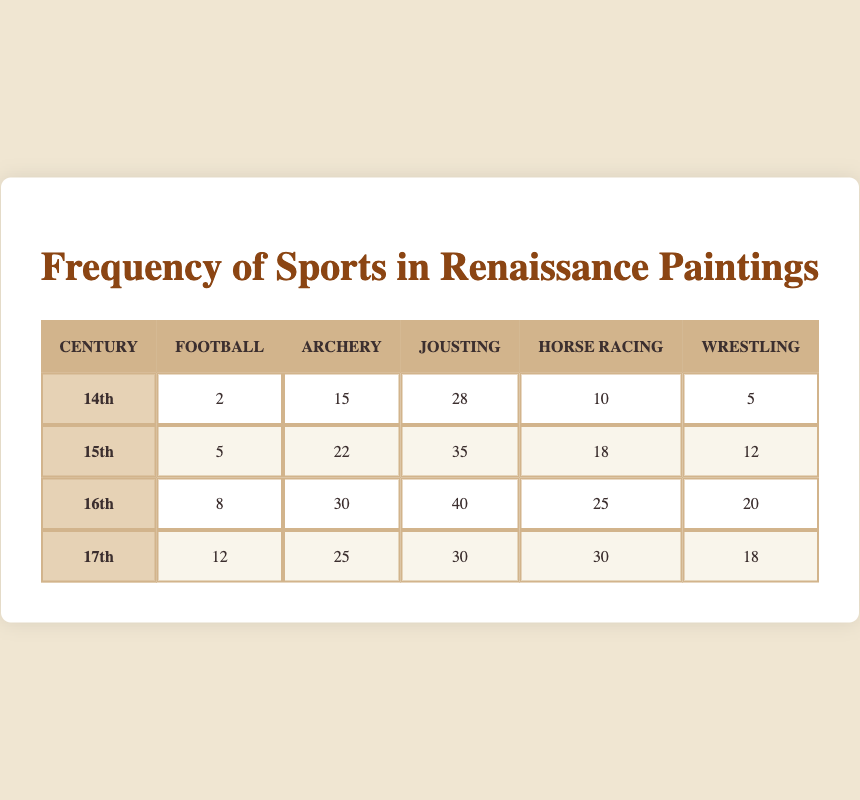What is the total number of archery depictions in the 16th century? The table shows that there are 30 depictions of archery in the 16th century, which is listed under the "Archery" column for that century.
Answer: 30 Which century has the highest frequency of wrestling depictions? By comparing the values in the wrestling column across all centuries, the 16th century has the highest frequency with 20 wrestlings depicted.
Answer: 16th century How many more instances of jousting are there in the 15th century compared to the 14th century? The table shows that there are 35 joustings in the 15th century and 28 in the 14th century. The difference is 35 - 28 = 7.
Answer: 7 Is the number of horse racing depictions in the 17th century greater than that in the 15th century? The table shows that there are 30 horse racing depictions in the 17th century and 18 in the 15th century. Since 30 is greater than 18, the statement is true.
Answer: Yes What is the total number of football, archery, jousting, horse racing, and wrestling depictions in the 14th century? The total can be calculated by adding all the values from the 14th century row: 2 (Football) + 15 (Archery) + 28 (Jousting) + 10 (Horse Racing) + 5 (Wrestling) = 60.
Answer: 60 In which century does archery have the lowest frequency of depiction? By examining the archery column across all centuries, the 14th century has the lowest frequency of 15 depictions.
Answer: 14th century What is the average number of football depictions across all centuries? To calculate the average, sum the football depictions: 2 + 5 + 8 + 12 = 27. Since there are 4 centuries, the average is 27 / 4 = 6.75.
Answer: 6.75 Which sport saw the most significant increase in depictions from the 14th to the 16th century? Analyzing the changes for each sport: Football increased from 2 to 8 (+6), Archery from 15 to 30 (+15), Jousting from 28 to 40 (+12), Horse Racing from 10 to 25 (+15), and Wrestling from 5 to 20 (+15). Archery saw the largest increase of 15 depictions.
Answer: Archery 